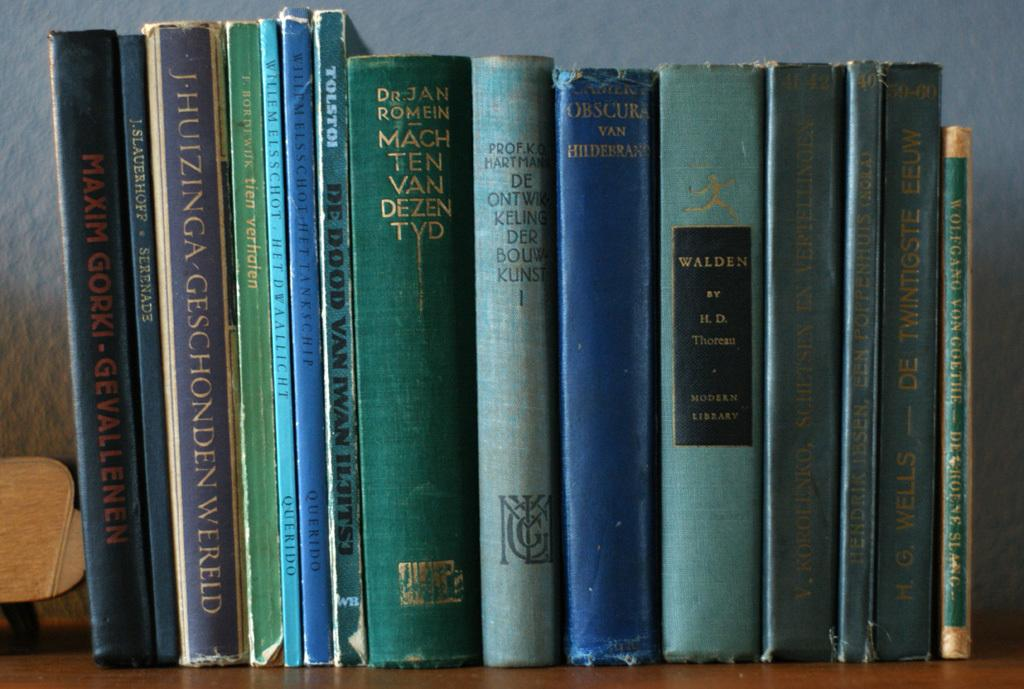Provide a one-sentence caption for the provided image. A collection of books on a shelf includes the title Walden by H.D. Thoreau. 